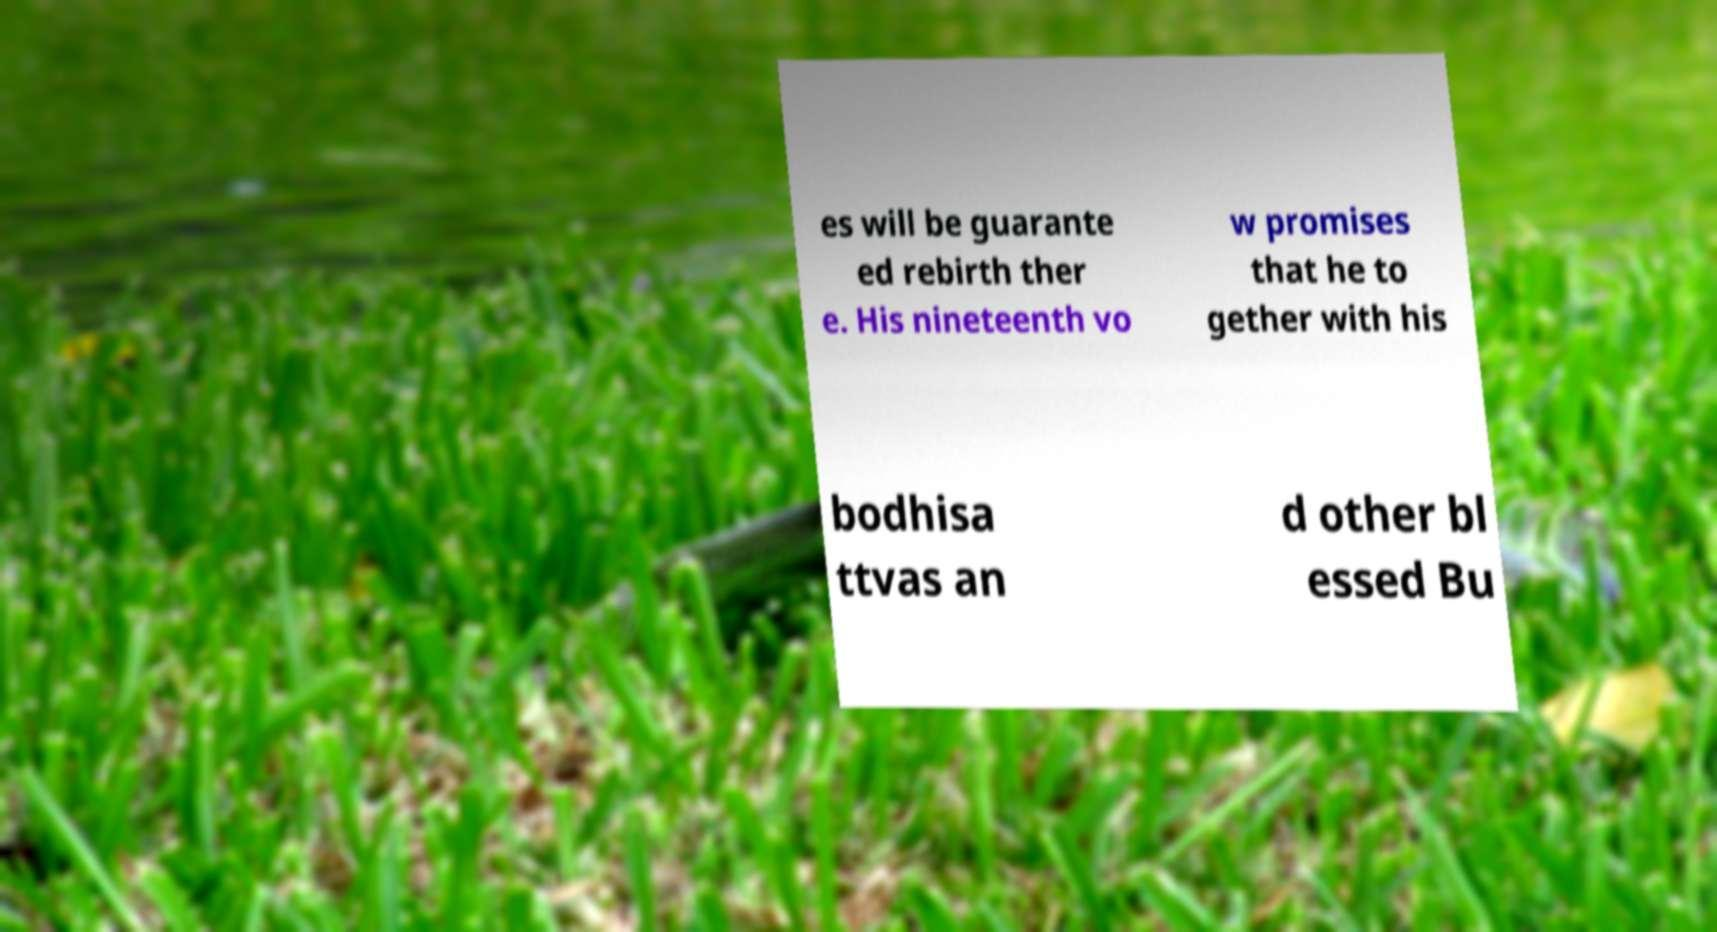Please identify and transcribe the text found in this image. es will be guarante ed rebirth ther e. His nineteenth vo w promises that he to gether with his bodhisa ttvas an d other bl essed Bu 